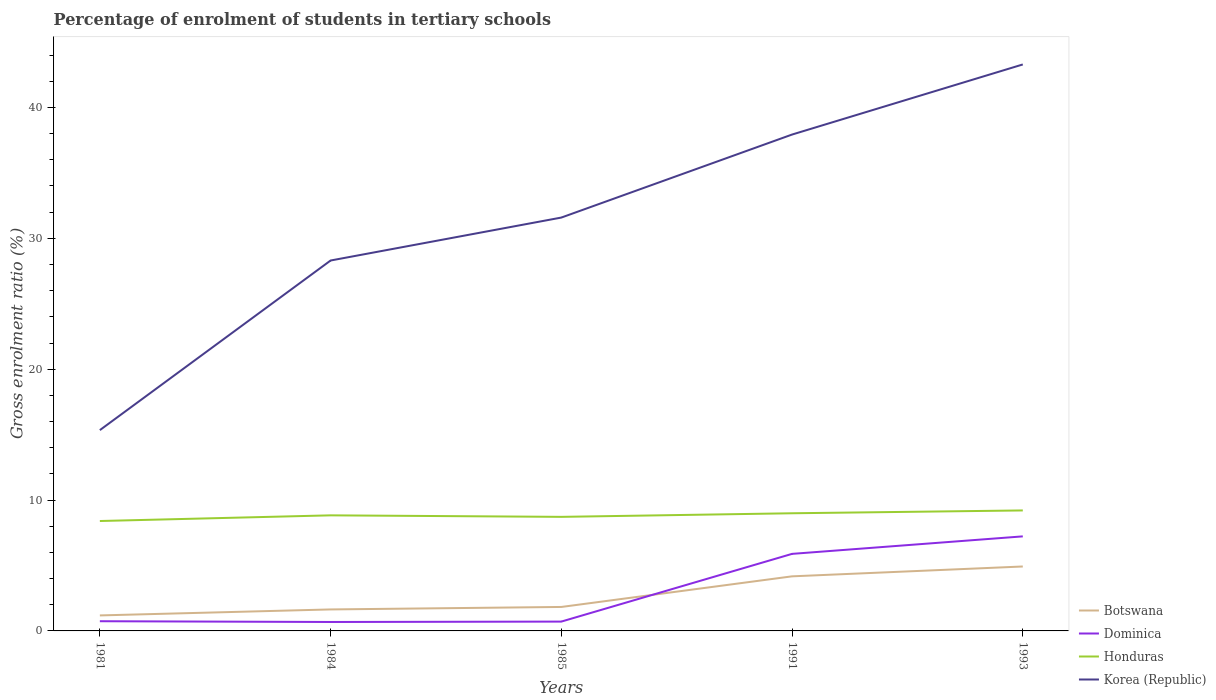How many different coloured lines are there?
Offer a terse response. 4. Across all years, what is the maximum percentage of students enrolled in tertiary schools in Dominica?
Your answer should be compact. 0.68. In which year was the percentage of students enrolled in tertiary schools in Botswana maximum?
Offer a very short reply. 1981. What is the total percentage of students enrolled in tertiary schools in Korea (Republic) in the graph?
Your answer should be very brief. -27.94. What is the difference between the highest and the second highest percentage of students enrolled in tertiary schools in Honduras?
Provide a succinct answer. 0.81. Is the percentage of students enrolled in tertiary schools in Dominica strictly greater than the percentage of students enrolled in tertiary schools in Honduras over the years?
Your answer should be compact. Yes. How many years are there in the graph?
Offer a very short reply. 5. What is the difference between two consecutive major ticks on the Y-axis?
Provide a succinct answer. 10. Does the graph contain any zero values?
Offer a very short reply. No. How many legend labels are there?
Your response must be concise. 4. How are the legend labels stacked?
Offer a terse response. Vertical. What is the title of the graph?
Provide a short and direct response. Percentage of enrolment of students in tertiary schools. Does "Equatorial Guinea" appear as one of the legend labels in the graph?
Your answer should be compact. No. What is the Gross enrolment ratio (%) of Botswana in 1981?
Give a very brief answer. 1.18. What is the Gross enrolment ratio (%) of Dominica in 1981?
Offer a terse response. 0.74. What is the Gross enrolment ratio (%) in Honduras in 1981?
Give a very brief answer. 8.4. What is the Gross enrolment ratio (%) of Korea (Republic) in 1981?
Give a very brief answer. 15.34. What is the Gross enrolment ratio (%) in Botswana in 1984?
Provide a succinct answer. 1.64. What is the Gross enrolment ratio (%) of Dominica in 1984?
Keep it short and to the point. 0.68. What is the Gross enrolment ratio (%) in Honduras in 1984?
Provide a succinct answer. 8.83. What is the Gross enrolment ratio (%) in Korea (Republic) in 1984?
Provide a succinct answer. 28.3. What is the Gross enrolment ratio (%) of Botswana in 1985?
Ensure brevity in your answer.  1.83. What is the Gross enrolment ratio (%) of Dominica in 1985?
Keep it short and to the point. 0.71. What is the Gross enrolment ratio (%) of Honduras in 1985?
Keep it short and to the point. 8.72. What is the Gross enrolment ratio (%) of Korea (Republic) in 1985?
Provide a succinct answer. 31.59. What is the Gross enrolment ratio (%) in Botswana in 1991?
Offer a very short reply. 4.17. What is the Gross enrolment ratio (%) of Dominica in 1991?
Give a very brief answer. 5.89. What is the Gross enrolment ratio (%) in Honduras in 1991?
Your answer should be very brief. 8.99. What is the Gross enrolment ratio (%) in Korea (Republic) in 1991?
Offer a terse response. 37.93. What is the Gross enrolment ratio (%) in Botswana in 1993?
Provide a succinct answer. 4.92. What is the Gross enrolment ratio (%) of Dominica in 1993?
Offer a terse response. 7.22. What is the Gross enrolment ratio (%) in Honduras in 1993?
Provide a succinct answer. 9.21. What is the Gross enrolment ratio (%) in Korea (Republic) in 1993?
Provide a short and direct response. 43.28. Across all years, what is the maximum Gross enrolment ratio (%) in Botswana?
Your answer should be compact. 4.92. Across all years, what is the maximum Gross enrolment ratio (%) in Dominica?
Provide a succinct answer. 7.22. Across all years, what is the maximum Gross enrolment ratio (%) of Honduras?
Offer a very short reply. 9.21. Across all years, what is the maximum Gross enrolment ratio (%) in Korea (Republic)?
Provide a short and direct response. 43.28. Across all years, what is the minimum Gross enrolment ratio (%) in Botswana?
Make the answer very short. 1.18. Across all years, what is the minimum Gross enrolment ratio (%) in Dominica?
Give a very brief answer. 0.68. Across all years, what is the minimum Gross enrolment ratio (%) of Honduras?
Offer a terse response. 8.4. Across all years, what is the minimum Gross enrolment ratio (%) in Korea (Republic)?
Ensure brevity in your answer.  15.34. What is the total Gross enrolment ratio (%) in Botswana in the graph?
Your answer should be very brief. 13.75. What is the total Gross enrolment ratio (%) in Dominica in the graph?
Ensure brevity in your answer.  15.25. What is the total Gross enrolment ratio (%) in Honduras in the graph?
Give a very brief answer. 44.14. What is the total Gross enrolment ratio (%) of Korea (Republic) in the graph?
Make the answer very short. 156.45. What is the difference between the Gross enrolment ratio (%) of Botswana in 1981 and that in 1984?
Give a very brief answer. -0.46. What is the difference between the Gross enrolment ratio (%) in Dominica in 1981 and that in 1984?
Keep it short and to the point. 0.06. What is the difference between the Gross enrolment ratio (%) of Honduras in 1981 and that in 1984?
Give a very brief answer. -0.43. What is the difference between the Gross enrolment ratio (%) in Korea (Republic) in 1981 and that in 1984?
Your answer should be very brief. -12.96. What is the difference between the Gross enrolment ratio (%) of Botswana in 1981 and that in 1985?
Ensure brevity in your answer.  -0.65. What is the difference between the Gross enrolment ratio (%) in Dominica in 1981 and that in 1985?
Ensure brevity in your answer.  0.03. What is the difference between the Gross enrolment ratio (%) of Honduras in 1981 and that in 1985?
Provide a short and direct response. -0.32. What is the difference between the Gross enrolment ratio (%) in Korea (Republic) in 1981 and that in 1985?
Ensure brevity in your answer.  -16.24. What is the difference between the Gross enrolment ratio (%) of Botswana in 1981 and that in 1991?
Keep it short and to the point. -2.99. What is the difference between the Gross enrolment ratio (%) in Dominica in 1981 and that in 1991?
Your answer should be very brief. -5.15. What is the difference between the Gross enrolment ratio (%) of Honduras in 1981 and that in 1991?
Your answer should be compact. -0.59. What is the difference between the Gross enrolment ratio (%) of Korea (Republic) in 1981 and that in 1991?
Give a very brief answer. -22.59. What is the difference between the Gross enrolment ratio (%) in Botswana in 1981 and that in 1993?
Provide a succinct answer. -3.74. What is the difference between the Gross enrolment ratio (%) in Dominica in 1981 and that in 1993?
Your answer should be compact. -6.48. What is the difference between the Gross enrolment ratio (%) in Honduras in 1981 and that in 1993?
Your answer should be compact. -0.81. What is the difference between the Gross enrolment ratio (%) of Korea (Republic) in 1981 and that in 1993?
Your response must be concise. -27.94. What is the difference between the Gross enrolment ratio (%) of Botswana in 1984 and that in 1985?
Offer a very short reply. -0.19. What is the difference between the Gross enrolment ratio (%) of Dominica in 1984 and that in 1985?
Your answer should be very brief. -0.03. What is the difference between the Gross enrolment ratio (%) of Honduras in 1984 and that in 1985?
Your answer should be very brief. 0.12. What is the difference between the Gross enrolment ratio (%) of Korea (Republic) in 1984 and that in 1985?
Give a very brief answer. -3.28. What is the difference between the Gross enrolment ratio (%) of Botswana in 1984 and that in 1991?
Offer a very short reply. -2.53. What is the difference between the Gross enrolment ratio (%) in Dominica in 1984 and that in 1991?
Provide a short and direct response. -5.2. What is the difference between the Gross enrolment ratio (%) in Honduras in 1984 and that in 1991?
Provide a succinct answer. -0.16. What is the difference between the Gross enrolment ratio (%) of Korea (Republic) in 1984 and that in 1991?
Offer a very short reply. -9.62. What is the difference between the Gross enrolment ratio (%) of Botswana in 1984 and that in 1993?
Give a very brief answer. -3.28. What is the difference between the Gross enrolment ratio (%) in Dominica in 1984 and that in 1993?
Give a very brief answer. -6.54. What is the difference between the Gross enrolment ratio (%) in Honduras in 1984 and that in 1993?
Make the answer very short. -0.37. What is the difference between the Gross enrolment ratio (%) of Korea (Republic) in 1984 and that in 1993?
Make the answer very short. -14.98. What is the difference between the Gross enrolment ratio (%) of Botswana in 1985 and that in 1991?
Provide a short and direct response. -2.34. What is the difference between the Gross enrolment ratio (%) of Dominica in 1985 and that in 1991?
Your response must be concise. -5.18. What is the difference between the Gross enrolment ratio (%) of Honduras in 1985 and that in 1991?
Offer a very short reply. -0.27. What is the difference between the Gross enrolment ratio (%) of Korea (Republic) in 1985 and that in 1991?
Offer a very short reply. -6.34. What is the difference between the Gross enrolment ratio (%) of Botswana in 1985 and that in 1993?
Give a very brief answer. -3.09. What is the difference between the Gross enrolment ratio (%) of Dominica in 1985 and that in 1993?
Offer a very short reply. -6.51. What is the difference between the Gross enrolment ratio (%) in Honduras in 1985 and that in 1993?
Give a very brief answer. -0.49. What is the difference between the Gross enrolment ratio (%) of Korea (Republic) in 1985 and that in 1993?
Your answer should be compact. -11.7. What is the difference between the Gross enrolment ratio (%) of Botswana in 1991 and that in 1993?
Your answer should be very brief. -0.75. What is the difference between the Gross enrolment ratio (%) in Dominica in 1991 and that in 1993?
Your response must be concise. -1.34. What is the difference between the Gross enrolment ratio (%) of Honduras in 1991 and that in 1993?
Ensure brevity in your answer.  -0.22. What is the difference between the Gross enrolment ratio (%) in Korea (Republic) in 1991 and that in 1993?
Your response must be concise. -5.36. What is the difference between the Gross enrolment ratio (%) in Botswana in 1981 and the Gross enrolment ratio (%) in Dominica in 1984?
Your answer should be compact. 0.5. What is the difference between the Gross enrolment ratio (%) in Botswana in 1981 and the Gross enrolment ratio (%) in Honduras in 1984?
Offer a terse response. -7.65. What is the difference between the Gross enrolment ratio (%) in Botswana in 1981 and the Gross enrolment ratio (%) in Korea (Republic) in 1984?
Give a very brief answer. -27.12. What is the difference between the Gross enrolment ratio (%) in Dominica in 1981 and the Gross enrolment ratio (%) in Honduras in 1984?
Your answer should be very brief. -8.09. What is the difference between the Gross enrolment ratio (%) in Dominica in 1981 and the Gross enrolment ratio (%) in Korea (Republic) in 1984?
Keep it short and to the point. -27.56. What is the difference between the Gross enrolment ratio (%) in Honduras in 1981 and the Gross enrolment ratio (%) in Korea (Republic) in 1984?
Make the answer very short. -19.91. What is the difference between the Gross enrolment ratio (%) of Botswana in 1981 and the Gross enrolment ratio (%) of Dominica in 1985?
Make the answer very short. 0.47. What is the difference between the Gross enrolment ratio (%) of Botswana in 1981 and the Gross enrolment ratio (%) of Honduras in 1985?
Provide a short and direct response. -7.53. What is the difference between the Gross enrolment ratio (%) in Botswana in 1981 and the Gross enrolment ratio (%) in Korea (Republic) in 1985?
Give a very brief answer. -30.4. What is the difference between the Gross enrolment ratio (%) in Dominica in 1981 and the Gross enrolment ratio (%) in Honduras in 1985?
Keep it short and to the point. -7.97. What is the difference between the Gross enrolment ratio (%) of Dominica in 1981 and the Gross enrolment ratio (%) of Korea (Republic) in 1985?
Your answer should be very brief. -30.84. What is the difference between the Gross enrolment ratio (%) of Honduras in 1981 and the Gross enrolment ratio (%) of Korea (Republic) in 1985?
Your answer should be very brief. -23.19. What is the difference between the Gross enrolment ratio (%) of Botswana in 1981 and the Gross enrolment ratio (%) of Dominica in 1991?
Ensure brevity in your answer.  -4.7. What is the difference between the Gross enrolment ratio (%) in Botswana in 1981 and the Gross enrolment ratio (%) in Honduras in 1991?
Your answer should be compact. -7.81. What is the difference between the Gross enrolment ratio (%) of Botswana in 1981 and the Gross enrolment ratio (%) of Korea (Republic) in 1991?
Make the answer very short. -36.74. What is the difference between the Gross enrolment ratio (%) in Dominica in 1981 and the Gross enrolment ratio (%) in Honduras in 1991?
Offer a very short reply. -8.25. What is the difference between the Gross enrolment ratio (%) of Dominica in 1981 and the Gross enrolment ratio (%) of Korea (Republic) in 1991?
Offer a terse response. -37.19. What is the difference between the Gross enrolment ratio (%) of Honduras in 1981 and the Gross enrolment ratio (%) of Korea (Republic) in 1991?
Offer a very short reply. -29.53. What is the difference between the Gross enrolment ratio (%) of Botswana in 1981 and the Gross enrolment ratio (%) of Dominica in 1993?
Provide a short and direct response. -6.04. What is the difference between the Gross enrolment ratio (%) of Botswana in 1981 and the Gross enrolment ratio (%) of Honduras in 1993?
Provide a succinct answer. -8.02. What is the difference between the Gross enrolment ratio (%) of Botswana in 1981 and the Gross enrolment ratio (%) of Korea (Republic) in 1993?
Provide a succinct answer. -42.1. What is the difference between the Gross enrolment ratio (%) in Dominica in 1981 and the Gross enrolment ratio (%) in Honduras in 1993?
Your answer should be compact. -8.46. What is the difference between the Gross enrolment ratio (%) in Dominica in 1981 and the Gross enrolment ratio (%) in Korea (Republic) in 1993?
Offer a very short reply. -42.54. What is the difference between the Gross enrolment ratio (%) of Honduras in 1981 and the Gross enrolment ratio (%) of Korea (Republic) in 1993?
Ensure brevity in your answer.  -34.89. What is the difference between the Gross enrolment ratio (%) of Botswana in 1984 and the Gross enrolment ratio (%) of Dominica in 1985?
Ensure brevity in your answer.  0.93. What is the difference between the Gross enrolment ratio (%) of Botswana in 1984 and the Gross enrolment ratio (%) of Honduras in 1985?
Offer a very short reply. -7.07. What is the difference between the Gross enrolment ratio (%) in Botswana in 1984 and the Gross enrolment ratio (%) in Korea (Republic) in 1985?
Make the answer very short. -29.94. What is the difference between the Gross enrolment ratio (%) of Dominica in 1984 and the Gross enrolment ratio (%) of Honduras in 1985?
Give a very brief answer. -8.03. What is the difference between the Gross enrolment ratio (%) in Dominica in 1984 and the Gross enrolment ratio (%) in Korea (Republic) in 1985?
Your answer should be compact. -30.9. What is the difference between the Gross enrolment ratio (%) in Honduras in 1984 and the Gross enrolment ratio (%) in Korea (Republic) in 1985?
Keep it short and to the point. -22.75. What is the difference between the Gross enrolment ratio (%) of Botswana in 1984 and the Gross enrolment ratio (%) of Dominica in 1991?
Offer a terse response. -4.25. What is the difference between the Gross enrolment ratio (%) of Botswana in 1984 and the Gross enrolment ratio (%) of Honduras in 1991?
Keep it short and to the point. -7.35. What is the difference between the Gross enrolment ratio (%) in Botswana in 1984 and the Gross enrolment ratio (%) in Korea (Republic) in 1991?
Provide a short and direct response. -36.29. What is the difference between the Gross enrolment ratio (%) in Dominica in 1984 and the Gross enrolment ratio (%) in Honduras in 1991?
Make the answer very short. -8.31. What is the difference between the Gross enrolment ratio (%) of Dominica in 1984 and the Gross enrolment ratio (%) of Korea (Republic) in 1991?
Offer a terse response. -37.25. What is the difference between the Gross enrolment ratio (%) of Honduras in 1984 and the Gross enrolment ratio (%) of Korea (Republic) in 1991?
Provide a short and direct response. -29.1. What is the difference between the Gross enrolment ratio (%) in Botswana in 1984 and the Gross enrolment ratio (%) in Dominica in 1993?
Offer a terse response. -5.58. What is the difference between the Gross enrolment ratio (%) in Botswana in 1984 and the Gross enrolment ratio (%) in Honduras in 1993?
Your response must be concise. -7.56. What is the difference between the Gross enrolment ratio (%) of Botswana in 1984 and the Gross enrolment ratio (%) of Korea (Republic) in 1993?
Make the answer very short. -41.64. What is the difference between the Gross enrolment ratio (%) of Dominica in 1984 and the Gross enrolment ratio (%) of Honduras in 1993?
Ensure brevity in your answer.  -8.52. What is the difference between the Gross enrolment ratio (%) of Dominica in 1984 and the Gross enrolment ratio (%) of Korea (Republic) in 1993?
Your answer should be compact. -42.6. What is the difference between the Gross enrolment ratio (%) of Honduras in 1984 and the Gross enrolment ratio (%) of Korea (Republic) in 1993?
Keep it short and to the point. -34.45. What is the difference between the Gross enrolment ratio (%) in Botswana in 1985 and the Gross enrolment ratio (%) in Dominica in 1991?
Provide a succinct answer. -4.06. What is the difference between the Gross enrolment ratio (%) of Botswana in 1985 and the Gross enrolment ratio (%) of Honduras in 1991?
Your answer should be compact. -7.16. What is the difference between the Gross enrolment ratio (%) in Botswana in 1985 and the Gross enrolment ratio (%) in Korea (Republic) in 1991?
Your response must be concise. -36.1. What is the difference between the Gross enrolment ratio (%) in Dominica in 1985 and the Gross enrolment ratio (%) in Honduras in 1991?
Ensure brevity in your answer.  -8.28. What is the difference between the Gross enrolment ratio (%) in Dominica in 1985 and the Gross enrolment ratio (%) in Korea (Republic) in 1991?
Offer a very short reply. -37.22. What is the difference between the Gross enrolment ratio (%) in Honduras in 1985 and the Gross enrolment ratio (%) in Korea (Republic) in 1991?
Provide a succinct answer. -29.21. What is the difference between the Gross enrolment ratio (%) of Botswana in 1985 and the Gross enrolment ratio (%) of Dominica in 1993?
Your response must be concise. -5.39. What is the difference between the Gross enrolment ratio (%) of Botswana in 1985 and the Gross enrolment ratio (%) of Honduras in 1993?
Your answer should be very brief. -7.38. What is the difference between the Gross enrolment ratio (%) of Botswana in 1985 and the Gross enrolment ratio (%) of Korea (Republic) in 1993?
Your answer should be compact. -41.45. What is the difference between the Gross enrolment ratio (%) in Dominica in 1985 and the Gross enrolment ratio (%) in Honduras in 1993?
Your answer should be compact. -8.49. What is the difference between the Gross enrolment ratio (%) in Dominica in 1985 and the Gross enrolment ratio (%) in Korea (Republic) in 1993?
Keep it short and to the point. -42.57. What is the difference between the Gross enrolment ratio (%) in Honduras in 1985 and the Gross enrolment ratio (%) in Korea (Republic) in 1993?
Your response must be concise. -34.57. What is the difference between the Gross enrolment ratio (%) in Botswana in 1991 and the Gross enrolment ratio (%) in Dominica in 1993?
Provide a succinct answer. -3.05. What is the difference between the Gross enrolment ratio (%) of Botswana in 1991 and the Gross enrolment ratio (%) of Honduras in 1993?
Offer a very short reply. -5.04. What is the difference between the Gross enrolment ratio (%) in Botswana in 1991 and the Gross enrolment ratio (%) in Korea (Republic) in 1993?
Offer a terse response. -39.11. What is the difference between the Gross enrolment ratio (%) of Dominica in 1991 and the Gross enrolment ratio (%) of Honduras in 1993?
Keep it short and to the point. -3.32. What is the difference between the Gross enrolment ratio (%) of Dominica in 1991 and the Gross enrolment ratio (%) of Korea (Republic) in 1993?
Offer a very short reply. -37.4. What is the difference between the Gross enrolment ratio (%) of Honduras in 1991 and the Gross enrolment ratio (%) of Korea (Republic) in 1993?
Offer a terse response. -34.29. What is the average Gross enrolment ratio (%) of Botswana per year?
Provide a succinct answer. 2.75. What is the average Gross enrolment ratio (%) of Dominica per year?
Provide a short and direct response. 3.05. What is the average Gross enrolment ratio (%) of Honduras per year?
Your answer should be very brief. 8.83. What is the average Gross enrolment ratio (%) of Korea (Republic) per year?
Your answer should be very brief. 31.29. In the year 1981, what is the difference between the Gross enrolment ratio (%) of Botswana and Gross enrolment ratio (%) of Dominica?
Your answer should be very brief. 0.44. In the year 1981, what is the difference between the Gross enrolment ratio (%) of Botswana and Gross enrolment ratio (%) of Honduras?
Ensure brevity in your answer.  -7.21. In the year 1981, what is the difference between the Gross enrolment ratio (%) in Botswana and Gross enrolment ratio (%) in Korea (Republic)?
Offer a terse response. -14.16. In the year 1981, what is the difference between the Gross enrolment ratio (%) of Dominica and Gross enrolment ratio (%) of Honduras?
Your response must be concise. -7.66. In the year 1981, what is the difference between the Gross enrolment ratio (%) of Dominica and Gross enrolment ratio (%) of Korea (Republic)?
Make the answer very short. -14.6. In the year 1981, what is the difference between the Gross enrolment ratio (%) in Honduras and Gross enrolment ratio (%) in Korea (Republic)?
Provide a short and direct response. -6.95. In the year 1984, what is the difference between the Gross enrolment ratio (%) in Botswana and Gross enrolment ratio (%) in Dominica?
Your response must be concise. 0.96. In the year 1984, what is the difference between the Gross enrolment ratio (%) of Botswana and Gross enrolment ratio (%) of Honduras?
Provide a succinct answer. -7.19. In the year 1984, what is the difference between the Gross enrolment ratio (%) in Botswana and Gross enrolment ratio (%) in Korea (Republic)?
Provide a succinct answer. -26.66. In the year 1984, what is the difference between the Gross enrolment ratio (%) of Dominica and Gross enrolment ratio (%) of Honduras?
Make the answer very short. -8.15. In the year 1984, what is the difference between the Gross enrolment ratio (%) of Dominica and Gross enrolment ratio (%) of Korea (Republic)?
Offer a very short reply. -27.62. In the year 1984, what is the difference between the Gross enrolment ratio (%) in Honduras and Gross enrolment ratio (%) in Korea (Republic)?
Ensure brevity in your answer.  -19.47. In the year 1985, what is the difference between the Gross enrolment ratio (%) in Botswana and Gross enrolment ratio (%) in Dominica?
Your answer should be very brief. 1.12. In the year 1985, what is the difference between the Gross enrolment ratio (%) in Botswana and Gross enrolment ratio (%) in Honduras?
Make the answer very short. -6.88. In the year 1985, what is the difference between the Gross enrolment ratio (%) in Botswana and Gross enrolment ratio (%) in Korea (Republic)?
Provide a succinct answer. -29.75. In the year 1985, what is the difference between the Gross enrolment ratio (%) of Dominica and Gross enrolment ratio (%) of Honduras?
Ensure brevity in your answer.  -8. In the year 1985, what is the difference between the Gross enrolment ratio (%) in Dominica and Gross enrolment ratio (%) in Korea (Republic)?
Keep it short and to the point. -30.87. In the year 1985, what is the difference between the Gross enrolment ratio (%) of Honduras and Gross enrolment ratio (%) of Korea (Republic)?
Your answer should be very brief. -22.87. In the year 1991, what is the difference between the Gross enrolment ratio (%) of Botswana and Gross enrolment ratio (%) of Dominica?
Provide a short and direct response. -1.72. In the year 1991, what is the difference between the Gross enrolment ratio (%) of Botswana and Gross enrolment ratio (%) of Honduras?
Give a very brief answer. -4.82. In the year 1991, what is the difference between the Gross enrolment ratio (%) of Botswana and Gross enrolment ratio (%) of Korea (Republic)?
Give a very brief answer. -33.76. In the year 1991, what is the difference between the Gross enrolment ratio (%) of Dominica and Gross enrolment ratio (%) of Honduras?
Your answer should be compact. -3.1. In the year 1991, what is the difference between the Gross enrolment ratio (%) of Dominica and Gross enrolment ratio (%) of Korea (Republic)?
Provide a short and direct response. -32.04. In the year 1991, what is the difference between the Gross enrolment ratio (%) of Honduras and Gross enrolment ratio (%) of Korea (Republic)?
Ensure brevity in your answer.  -28.94. In the year 1993, what is the difference between the Gross enrolment ratio (%) in Botswana and Gross enrolment ratio (%) in Dominica?
Provide a succinct answer. -2.3. In the year 1993, what is the difference between the Gross enrolment ratio (%) in Botswana and Gross enrolment ratio (%) in Honduras?
Provide a short and direct response. -4.28. In the year 1993, what is the difference between the Gross enrolment ratio (%) of Botswana and Gross enrolment ratio (%) of Korea (Republic)?
Provide a succinct answer. -38.36. In the year 1993, what is the difference between the Gross enrolment ratio (%) in Dominica and Gross enrolment ratio (%) in Honduras?
Keep it short and to the point. -1.98. In the year 1993, what is the difference between the Gross enrolment ratio (%) in Dominica and Gross enrolment ratio (%) in Korea (Republic)?
Offer a very short reply. -36.06. In the year 1993, what is the difference between the Gross enrolment ratio (%) of Honduras and Gross enrolment ratio (%) of Korea (Republic)?
Your answer should be compact. -34.08. What is the ratio of the Gross enrolment ratio (%) of Botswana in 1981 to that in 1984?
Provide a short and direct response. 0.72. What is the ratio of the Gross enrolment ratio (%) in Dominica in 1981 to that in 1984?
Provide a succinct answer. 1.09. What is the ratio of the Gross enrolment ratio (%) of Honduras in 1981 to that in 1984?
Give a very brief answer. 0.95. What is the ratio of the Gross enrolment ratio (%) in Korea (Republic) in 1981 to that in 1984?
Your answer should be compact. 0.54. What is the ratio of the Gross enrolment ratio (%) in Botswana in 1981 to that in 1985?
Your answer should be compact. 0.65. What is the ratio of the Gross enrolment ratio (%) of Dominica in 1981 to that in 1985?
Offer a terse response. 1.04. What is the ratio of the Gross enrolment ratio (%) of Honduras in 1981 to that in 1985?
Your answer should be compact. 0.96. What is the ratio of the Gross enrolment ratio (%) in Korea (Republic) in 1981 to that in 1985?
Provide a short and direct response. 0.49. What is the ratio of the Gross enrolment ratio (%) of Botswana in 1981 to that in 1991?
Ensure brevity in your answer.  0.28. What is the ratio of the Gross enrolment ratio (%) in Dominica in 1981 to that in 1991?
Your answer should be compact. 0.13. What is the ratio of the Gross enrolment ratio (%) of Honduras in 1981 to that in 1991?
Your answer should be very brief. 0.93. What is the ratio of the Gross enrolment ratio (%) of Korea (Republic) in 1981 to that in 1991?
Provide a succinct answer. 0.4. What is the ratio of the Gross enrolment ratio (%) in Botswana in 1981 to that in 1993?
Give a very brief answer. 0.24. What is the ratio of the Gross enrolment ratio (%) of Dominica in 1981 to that in 1993?
Your answer should be compact. 0.1. What is the ratio of the Gross enrolment ratio (%) of Honduras in 1981 to that in 1993?
Keep it short and to the point. 0.91. What is the ratio of the Gross enrolment ratio (%) of Korea (Republic) in 1981 to that in 1993?
Provide a short and direct response. 0.35. What is the ratio of the Gross enrolment ratio (%) of Botswana in 1984 to that in 1985?
Give a very brief answer. 0.9. What is the ratio of the Gross enrolment ratio (%) in Dominica in 1984 to that in 1985?
Offer a very short reply. 0.96. What is the ratio of the Gross enrolment ratio (%) of Honduras in 1984 to that in 1985?
Give a very brief answer. 1.01. What is the ratio of the Gross enrolment ratio (%) in Korea (Republic) in 1984 to that in 1985?
Offer a terse response. 0.9. What is the ratio of the Gross enrolment ratio (%) in Botswana in 1984 to that in 1991?
Provide a short and direct response. 0.39. What is the ratio of the Gross enrolment ratio (%) of Dominica in 1984 to that in 1991?
Ensure brevity in your answer.  0.12. What is the ratio of the Gross enrolment ratio (%) in Honduras in 1984 to that in 1991?
Offer a terse response. 0.98. What is the ratio of the Gross enrolment ratio (%) of Korea (Republic) in 1984 to that in 1991?
Your response must be concise. 0.75. What is the ratio of the Gross enrolment ratio (%) in Botswana in 1984 to that in 1993?
Give a very brief answer. 0.33. What is the ratio of the Gross enrolment ratio (%) of Dominica in 1984 to that in 1993?
Your answer should be very brief. 0.09. What is the ratio of the Gross enrolment ratio (%) of Honduras in 1984 to that in 1993?
Keep it short and to the point. 0.96. What is the ratio of the Gross enrolment ratio (%) of Korea (Republic) in 1984 to that in 1993?
Provide a short and direct response. 0.65. What is the ratio of the Gross enrolment ratio (%) of Botswana in 1985 to that in 1991?
Offer a terse response. 0.44. What is the ratio of the Gross enrolment ratio (%) of Dominica in 1985 to that in 1991?
Ensure brevity in your answer.  0.12. What is the ratio of the Gross enrolment ratio (%) of Honduras in 1985 to that in 1991?
Provide a succinct answer. 0.97. What is the ratio of the Gross enrolment ratio (%) in Korea (Republic) in 1985 to that in 1991?
Your answer should be compact. 0.83. What is the ratio of the Gross enrolment ratio (%) in Botswana in 1985 to that in 1993?
Keep it short and to the point. 0.37. What is the ratio of the Gross enrolment ratio (%) in Dominica in 1985 to that in 1993?
Your response must be concise. 0.1. What is the ratio of the Gross enrolment ratio (%) of Honduras in 1985 to that in 1993?
Your answer should be compact. 0.95. What is the ratio of the Gross enrolment ratio (%) of Korea (Republic) in 1985 to that in 1993?
Your answer should be very brief. 0.73. What is the ratio of the Gross enrolment ratio (%) in Botswana in 1991 to that in 1993?
Your response must be concise. 0.85. What is the ratio of the Gross enrolment ratio (%) in Dominica in 1991 to that in 1993?
Your answer should be very brief. 0.81. What is the ratio of the Gross enrolment ratio (%) in Honduras in 1991 to that in 1993?
Your answer should be very brief. 0.98. What is the ratio of the Gross enrolment ratio (%) of Korea (Republic) in 1991 to that in 1993?
Keep it short and to the point. 0.88. What is the difference between the highest and the second highest Gross enrolment ratio (%) of Botswana?
Offer a terse response. 0.75. What is the difference between the highest and the second highest Gross enrolment ratio (%) in Dominica?
Keep it short and to the point. 1.34. What is the difference between the highest and the second highest Gross enrolment ratio (%) in Honduras?
Your response must be concise. 0.22. What is the difference between the highest and the second highest Gross enrolment ratio (%) in Korea (Republic)?
Your answer should be very brief. 5.36. What is the difference between the highest and the lowest Gross enrolment ratio (%) of Botswana?
Provide a short and direct response. 3.74. What is the difference between the highest and the lowest Gross enrolment ratio (%) in Dominica?
Offer a terse response. 6.54. What is the difference between the highest and the lowest Gross enrolment ratio (%) of Honduras?
Keep it short and to the point. 0.81. What is the difference between the highest and the lowest Gross enrolment ratio (%) of Korea (Republic)?
Make the answer very short. 27.94. 